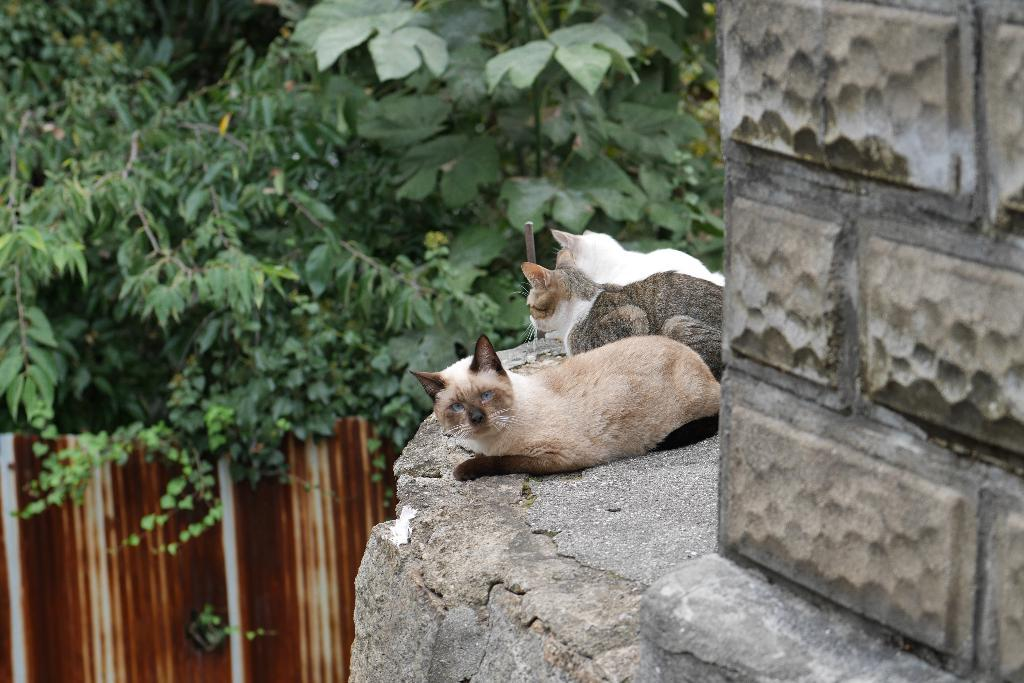How many cats can be seen in the image? There are three cats in the image. Where are the cats located? The cats are sitting on a wall. What else can be seen in the image besides the cats? Roof sheets are present in the image. What is visible in the background of the image? There are trees in the background of the image. Can you tell me how many basketballs are being used by the cats in the image? There are no basketballs present in the image; it features three cats sitting on a wall. What type of loaf is being consumed by the cats in the image? There is no loaf present in the image; the cats are sitting on a wall without any food items. 